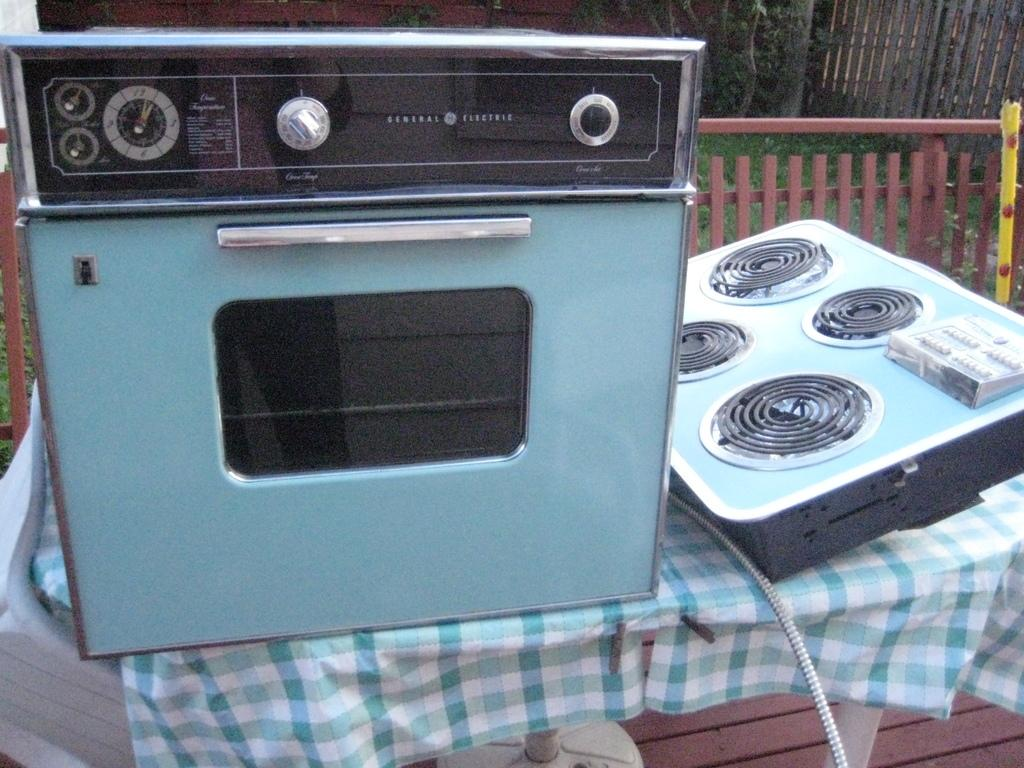<image>
Describe the image concisely. A small blue oven which has the word General along the top. 